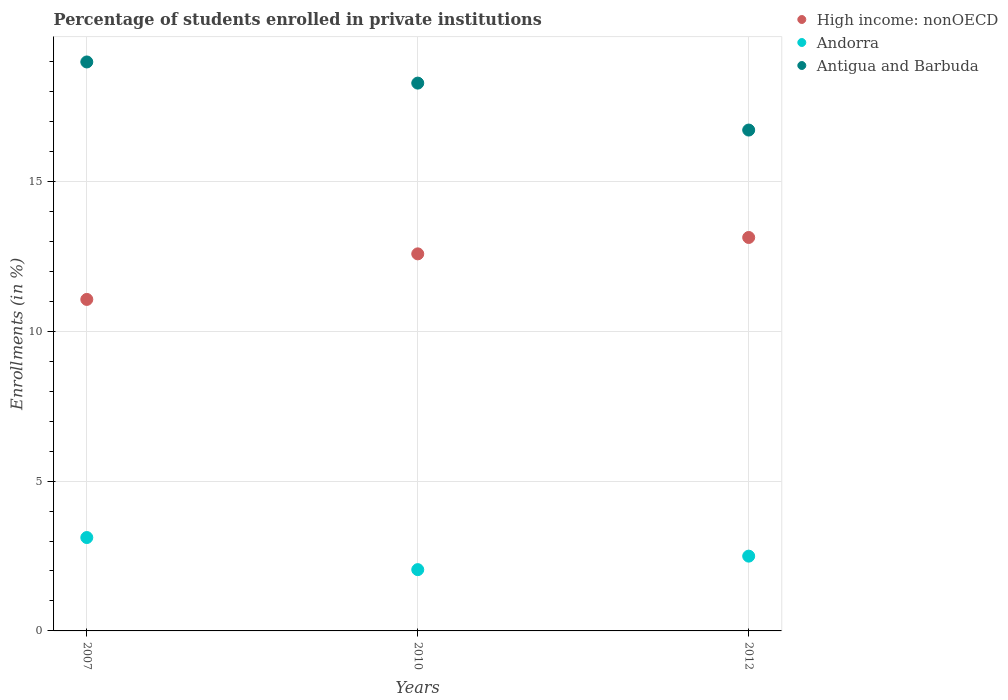What is the percentage of trained teachers in High income: nonOECD in 2007?
Provide a succinct answer. 11.06. Across all years, what is the maximum percentage of trained teachers in High income: nonOECD?
Provide a short and direct response. 13.13. Across all years, what is the minimum percentage of trained teachers in Antigua and Barbuda?
Your answer should be compact. 16.71. In which year was the percentage of trained teachers in High income: nonOECD maximum?
Provide a succinct answer. 2012. What is the total percentage of trained teachers in Antigua and Barbuda in the graph?
Provide a succinct answer. 53.98. What is the difference between the percentage of trained teachers in Andorra in 2010 and that in 2012?
Provide a short and direct response. -0.45. What is the difference between the percentage of trained teachers in Antigua and Barbuda in 2007 and the percentage of trained teachers in Andorra in 2010?
Ensure brevity in your answer.  16.94. What is the average percentage of trained teachers in Antigua and Barbuda per year?
Offer a very short reply. 17.99. In the year 2007, what is the difference between the percentage of trained teachers in High income: nonOECD and percentage of trained teachers in Andorra?
Your answer should be compact. 7.95. What is the ratio of the percentage of trained teachers in Antigua and Barbuda in 2010 to that in 2012?
Your response must be concise. 1.09. Is the percentage of trained teachers in High income: nonOECD in 2007 less than that in 2012?
Keep it short and to the point. Yes. What is the difference between the highest and the second highest percentage of trained teachers in Antigua and Barbuda?
Provide a short and direct response. 0.71. What is the difference between the highest and the lowest percentage of trained teachers in High income: nonOECD?
Your answer should be compact. 2.07. Does the percentage of trained teachers in Antigua and Barbuda monotonically increase over the years?
Offer a terse response. No. Is the percentage of trained teachers in Andorra strictly greater than the percentage of trained teachers in High income: nonOECD over the years?
Offer a very short reply. No. How many dotlines are there?
Provide a short and direct response. 3. What is the difference between two consecutive major ticks on the Y-axis?
Your answer should be very brief. 5. Does the graph contain any zero values?
Give a very brief answer. No. What is the title of the graph?
Offer a terse response. Percentage of students enrolled in private institutions. Does "Chad" appear as one of the legend labels in the graph?
Provide a succinct answer. No. What is the label or title of the X-axis?
Give a very brief answer. Years. What is the label or title of the Y-axis?
Your response must be concise. Enrollments (in %). What is the Enrollments (in %) of High income: nonOECD in 2007?
Make the answer very short. 11.06. What is the Enrollments (in %) in Andorra in 2007?
Ensure brevity in your answer.  3.12. What is the Enrollments (in %) of Antigua and Barbuda in 2007?
Ensure brevity in your answer.  18.98. What is the Enrollments (in %) in High income: nonOECD in 2010?
Give a very brief answer. 12.58. What is the Enrollments (in %) in Andorra in 2010?
Keep it short and to the point. 2.04. What is the Enrollments (in %) of Antigua and Barbuda in 2010?
Your answer should be very brief. 18.28. What is the Enrollments (in %) of High income: nonOECD in 2012?
Give a very brief answer. 13.13. What is the Enrollments (in %) in Andorra in 2012?
Ensure brevity in your answer.  2.5. What is the Enrollments (in %) in Antigua and Barbuda in 2012?
Your response must be concise. 16.71. Across all years, what is the maximum Enrollments (in %) of High income: nonOECD?
Your answer should be compact. 13.13. Across all years, what is the maximum Enrollments (in %) in Andorra?
Provide a succinct answer. 3.12. Across all years, what is the maximum Enrollments (in %) in Antigua and Barbuda?
Your response must be concise. 18.98. Across all years, what is the minimum Enrollments (in %) in High income: nonOECD?
Give a very brief answer. 11.06. Across all years, what is the minimum Enrollments (in %) of Andorra?
Your answer should be very brief. 2.04. Across all years, what is the minimum Enrollments (in %) in Antigua and Barbuda?
Provide a short and direct response. 16.71. What is the total Enrollments (in %) of High income: nonOECD in the graph?
Keep it short and to the point. 36.77. What is the total Enrollments (in %) of Andorra in the graph?
Your answer should be very brief. 7.66. What is the total Enrollments (in %) of Antigua and Barbuda in the graph?
Ensure brevity in your answer.  53.98. What is the difference between the Enrollments (in %) of High income: nonOECD in 2007 and that in 2010?
Your response must be concise. -1.52. What is the difference between the Enrollments (in %) of Andorra in 2007 and that in 2010?
Your response must be concise. 1.07. What is the difference between the Enrollments (in %) in Antigua and Barbuda in 2007 and that in 2010?
Provide a succinct answer. 0.71. What is the difference between the Enrollments (in %) in High income: nonOECD in 2007 and that in 2012?
Your response must be concise. -2.07. What is the difference between the Enrollments (in %) in Andorra in 2007 and that in 2012?
Your answer should be very brief. 0.62. What is the difference between the Enrollments (in %) in Antigua and Barbuda in 2007 and that in 2012?
Make the answer very short. 2.27. What is the difference between the Enrollments (in %) of High income: nonOECD in 2010 and that in 2012?
Provide a short and direct response. -0.55. What is the difference between the Enrollments (in %) in Andorra in 2010 and that in 2012?
Your answer should be very brief. -0.45. What is the difference between the Enrollments (in %) of Antigua and Barbuda in 2010 and that in 2012?
Your answer should be compact. 1.57. What is the difference between the Enrollments (in %) of High income: nonOECD in 2007 and the Enrollments (in %) of Andorra in 2010?
Your answer should be very brief. 9.02. What is the difference between the Enrollments (in %) in High income: nonOECD in 2007 and the Enrollments (in %) in Antigua and Barbuda in 2010?
Offer a very short reply. -7.22. What is the difference between the Enrollments (in %) of Andorra in 2007 and the Enrollments (in %) of Antigua and Barbuda in 2010?
Keep it short and to the point. -15.16. What is the difference between the Enrollments (in %) of High income: nonOECD in 2007 and the Enrollments (in %) of Andorra in 2012?
Ensure brevity in your answer.  8.57. What is the difference between the Enrollments (in %) in High income: nonOECD in 2007 and the Enrollments (in %) in Antigua and Barbuda in 2012?
Make the answer very short. -5.65. What is the difference between the Enrollments (in %) in Andorra in 2007 and the Enrollments (in %) in Antigua and Barbuda in 2012?
Make the answer very short. -13.6. What is the difference between the Enrollments (in %) of High income: nonOECD in 2010 and the Enrollments (in %) of Andorra in 2012?
Make the answer very short. 10.09. What is the difference between the Enrollments (in %) in High income: nonOECD in 2010 and the Enrollments (in %) in Antigua and Barbuda in 2012?
Ensure brevity in your answer.  -4.13. What is the difference between the Enrollments (in %) of Andorra in 2010 and the Enrollments (in %) of Antigua and Barbuda in 2012?
Your response must be concise. -14.67. What is the average Enrollments (in %) of High income: nonOECD per year?
Make the answer very short. 12.26. What is the average Enrollments (in %) in Andorra per year?
Keep it short and to the point. 2.55. What is the average Enrollments (in %) in Antigua and Barbuda per year?
Make the answer very short. 17.99. In the year 2007, what is the difference between the Enrollments (in %) of High income: nonOECD and Enrollments (in %) of Andorra?
Your response must be concise. 7.95. In the year 2007, what is the difference between the Enrollments (in %) of High income: nonOECD and Enrollments (in %) of Antigua and Barbuda?
Ensure brevity in your answer.  -7.92. In the year 2007, what is the difference between the Enrollments (in %) in Andorra and Enrollments (in %) in Antigua and Barbuda?
Your answer should be compact. -15.87. In the year 2010, what is the difference between the Enrollments (in %) in High income: nonOECD and Enrollments (in %) in Andorra?
Provide a succinct answer. 10.54. In the year 2010, what is the difference between the Enrollments (in %) in High income: nonOECD and Enrollments (in %) in Antigua and Barbuda?
Provide a succinct answer. -5.7. In the year 2010, what is the difference between the Enrollments (in %) in Andorra and Enrollments (in %) in Antigua and Barbuda?
Offer a terse response. -16.23. In the year 2012, what is the difference between the Enrollments (in %) of High income: nonOECD and Enrollments (in %) of Andorra?
Give a very brief answer. 10.63. In the year 2012, what is the difference between the Enrollments (in %) of High income: nonOECD and Enrollments (in %) of Antigua and Barbuda?
Keep it short and to the point. -3.58. In the year 2012, what is the difference between the Enrollments (in %) in Andorra and Enrollments (in %) in Antigua and Barbuda?
Your answer should be very brief. -14.22. What is the ratio of the Enrollments (in %) in High income: nonOECD in 2007 to that in 2010?
Provide a short and direct response. 0.88. What is the ratio of the Enrollments (in %) in Andorra in 2007 to that in 2010?
Your response must be concise. 1.52. What is the ratio of the Enrollments (in %) of Antigua and Barbuda in 2007 to that in 2010?
Provide a succinct answer. 1.04. What is the ratio of the Enrollments (in %) of High income: nonOECD in 2007 to that in 2012?
Your answer should be compact. 0.84. What is the ratio of the Enrollments (in %) of Andorra in 2007 to that in 2012?
Provide a short and direct response. 1.25. What is the ratio of the Enrollments (in %) of Antigua and Barbuda in 2007 to that in 2012?
Provide a succinct answer. 1.14. What is the ratio of the Enrollments (in %) of High income: nonOECD in 2010 to that in 2012?
Give a very brief answer. 0.96. What is the ratio of the Enrollments (in %) of Andorra in 2010 to that in 2012?
Ensure brevity in your answer.  0.82. What is the ratio of the Enrollments (in %) of Antigua and Barbuda in 2010 to that in 2012?
Offer a very short reply. 1.09. What is the difference between the highest and the second highest Enrollments (in %) of High income: nonOECD?
Offer a very short reply. 0.55. What is the difference between the highest and the second highest Enrollments (in %) in Andorra?
Your answer should be compact. 0.62. What is the difference between the highest and the second highest Enrollments (in %) of Antigua and Barbuda?
Provide a short and direct response. 0.71. What is the difference between the highest and the lowest Enrollments (in %) in High income: nonOECD?
Your response must be concise. 2.07. What is the difference between the highest and the lowest Enrollments (in %) of Andorra?
Provide a short and direct response. 1.07. What is the difference between the highest and the lowest Enrollments (in %) of Antigua and Barbuda?
Provide a succinct answer. 2.27. 